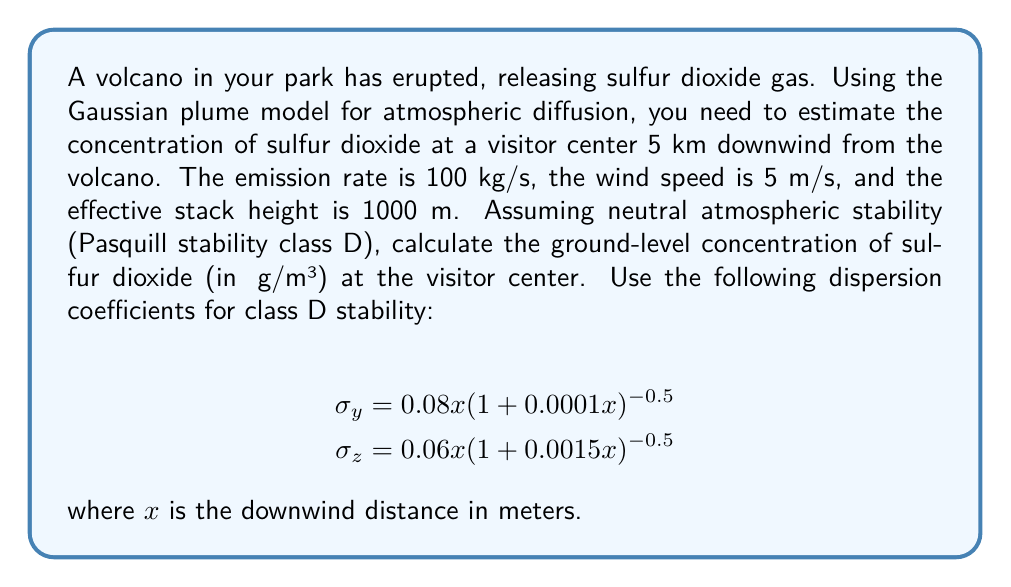Can you solve this math problem? To solve this problem, we'll use the Gaussian plume model equation for ground-level concentration:

$$C(x,0,0) = \frac{Q}{2\pi u \sigma_y \sigma_z} \exp\left(-\frac{H^2}{2\sigma_z^2}\right)$$

Where:
$C(x,0,0)$ is the ground-level concentration at distance $x$ downwind
$Q$ is the emission rate (100 kg/s = 100,000,000 μg/s)
$u$ is the wind speed (5 m/s)
$H$ is the effective stack height (1000 m)
$\sigma_y$ and $\sigma_z$ are the dispersion coefficients

Step 1: Calculate $\sigma_y$ and $\sigma_z$ at $x = 5000$ m
$$\sigma_y = 0.08(5000)(1+0.0001(5000))^{-0.5} = 352.75 \text{ m}$$
$$\sigma_z = 0.06(5000)(1+0.0015(5000))^{-0.5} = 162.45 \text{ m}$$

Step 2: Substitute values into the Gaussian plume model equation
$$C(5000,0,0) = \frac{100,000,000}{2\pi(5)(352.75)(162.45)} \exp\left(-\frac{1000^2}{2(162.45)^2}\right)$$

Step 3: Calculate the exponent term
$$\exp\left(-\frac{1000^2}{2(162.45)^2}\right) = \exp(-18.93) = 5.99 \times 10^{-9}$$

Step 4: Calculate the final concentration
$$C(5000,0,0) = \frac{100,000,000}{2\pi(5)(352.75)(162.45)} (5.99 \times 10^{-9})$$
$$C(5000,0,0) = 0.0103 \text{ μg/m³}$$
Answer: 0.0103 μg/m³ 